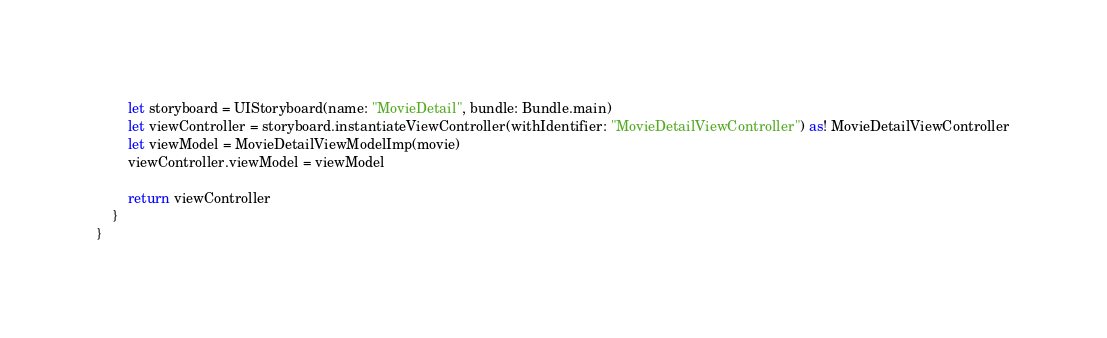Convert code to text. <code><loc_0><loc_0><loc_500><loc_500><_Swift_>        let storyboard = UIStoryboard(name: "MovieDetail", bundle: Bundle.main)
        let viewController = storyboard.instantiateViewController(withIdentifier: "MovieDetailViewController") as! MovieDetailViewController
        let viewModel = MovieDetailViewModelImp(movie)
        viewController.viewModel = viewModel
        
        return viewController
    }
}
</code> 